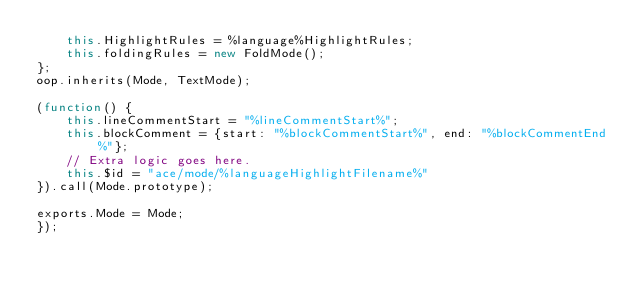Convert code to text. <code><loc_0><loc_0><loc_500><loc_500><_JavaScript_>    this.HighlightRules = %language%HighlightRules;
    this.foldingRules = new FoldMode();
};
oop.inherits(Mode, TextMode);

(function() {
    this.lineCommentStart = "%lineCommentStart%";
    this.blockComment = {start: "%blockCommentStart%", end: "%blockCommentEnd%"};
    // Extra logic goes here.
    this.$id = "ace/mode/%languageHighlightFilename%"
}).call(Mode.prototype);

exports.Mode = Mode;
});</code> 